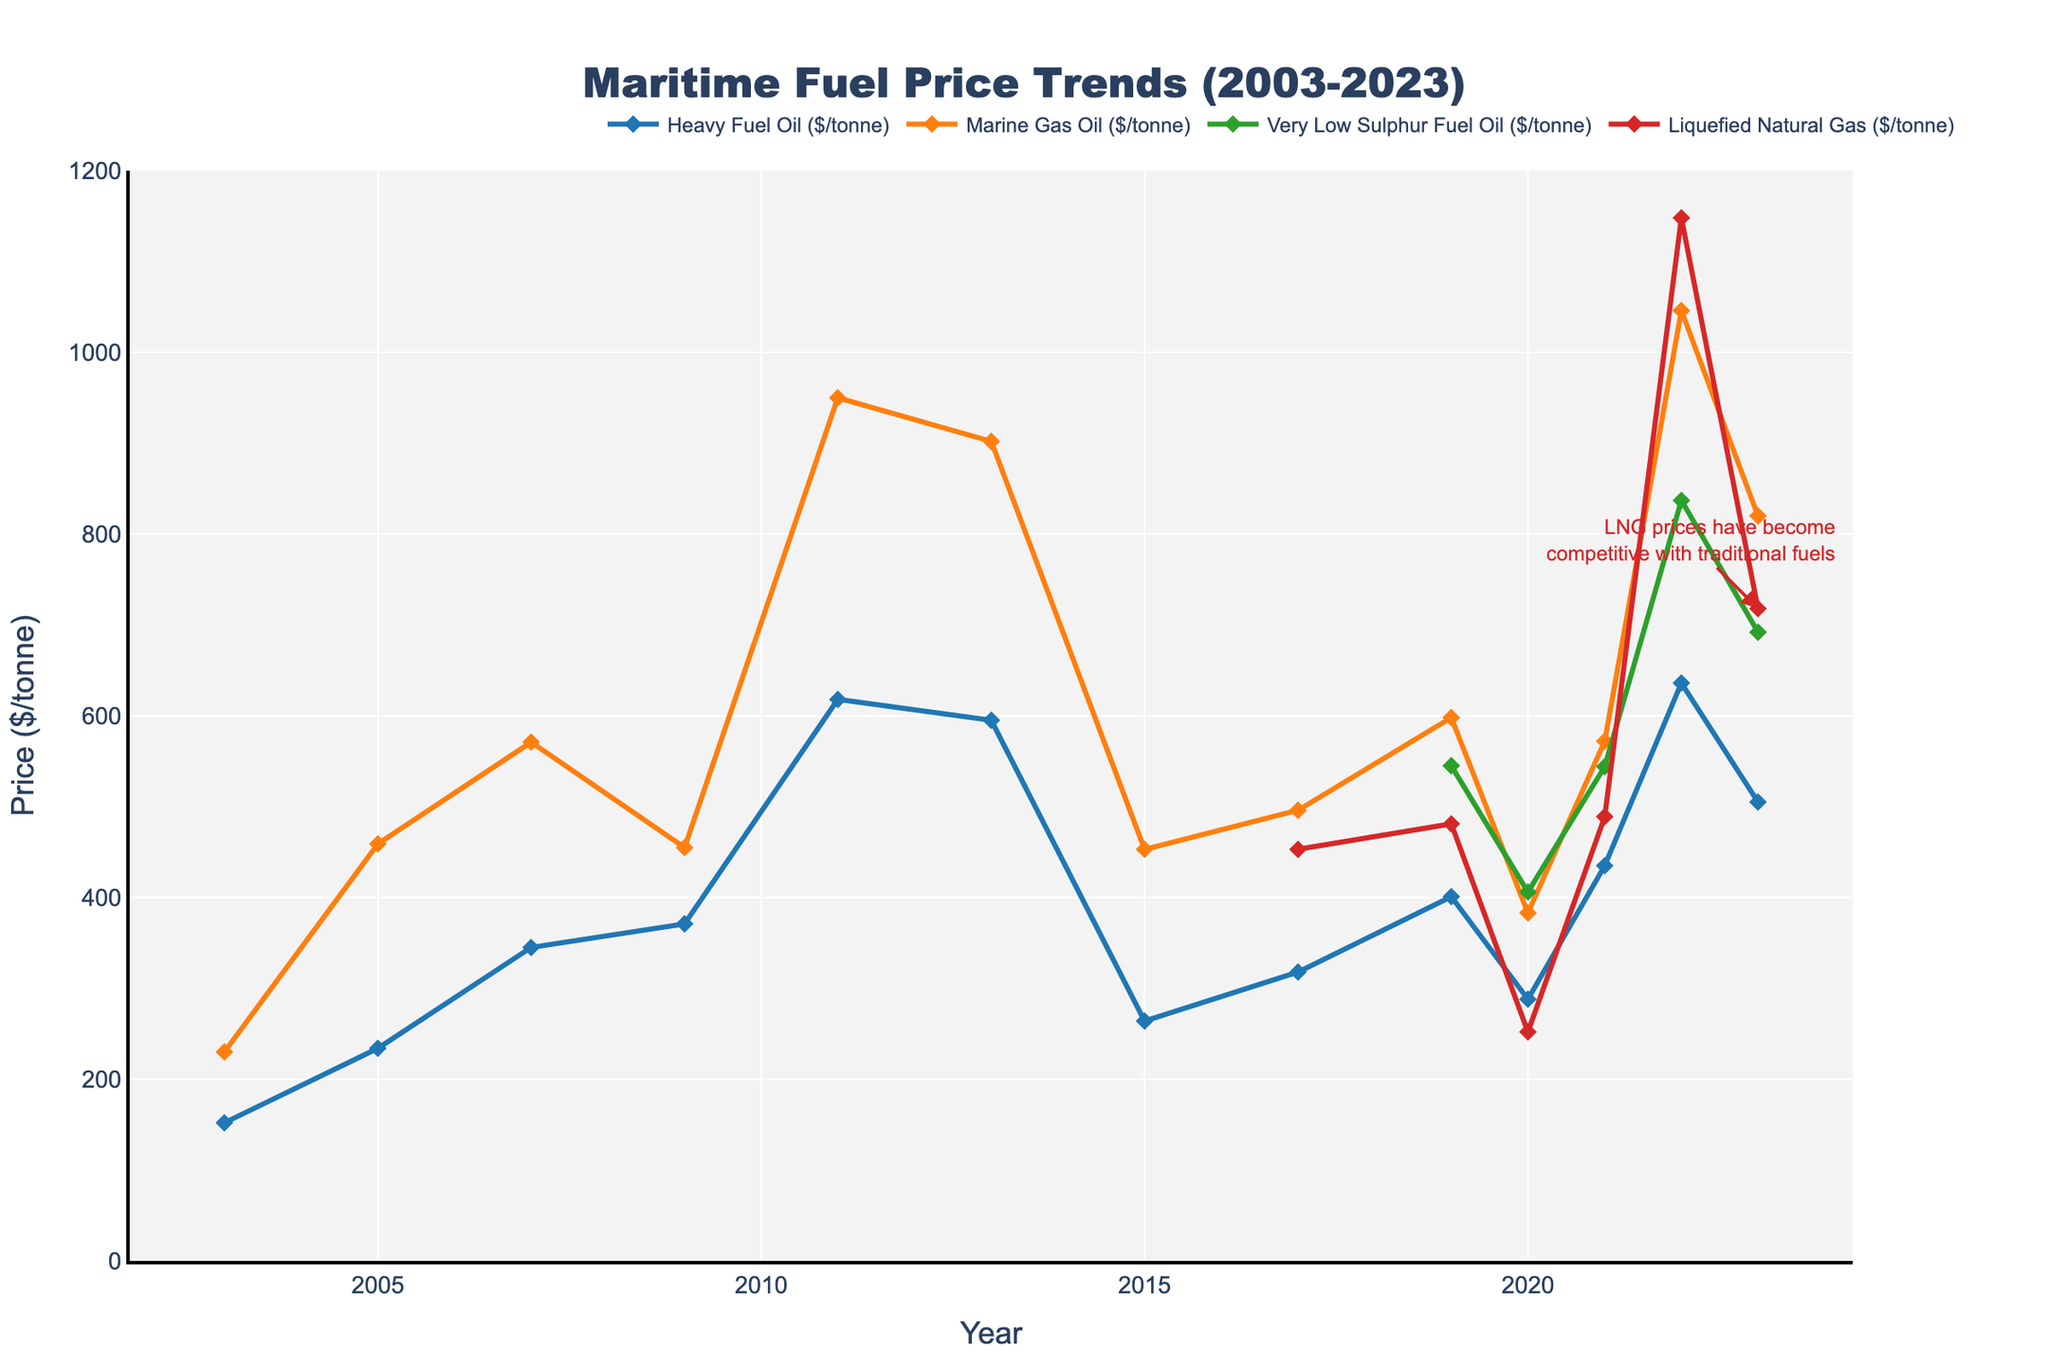What is the price trend of Heavy Fuel Oil (HFO) from 2005 to 2015? From the figure, locate the data points for HFO in 2005, 2007, 2009, 2011, 2013, and 2015. Observe how the price changes over these years. The price increases from 234 in 2005 to 371 in 2009, peaks at 618 in 2011, and decreases significantly to 264 in 2015.
Answer: Increase How do the prices of Marine Gas Oil (MGO) and Very Low Sulphur Fuel Oil (VLSFO) compare in 2019? From the figure, find the prices of MGO and VLSFO in 2019 by looking at the corresponding points on the graph. MGO is priced at 598 and VLSFO is priced at 545. Comparing these, MGO is higher.
Answer: MGO is higher Which year saw the highest price for Marine Gas Oil (MGO), and what was the price? Determine the highest point on the MGO curve, which appears around 2022. The price at this point, which is the highest, is approximately 1046.
Answer: 2022, 1046 What is the average price of Liquefied Natural Gas (LNG) over the years it is available on the chart? Sum the prices of LNG for the years available (2017, 2019, 2020, 2021, 2022, 2023) and divide by the number of years. The sum is 453 + 481 + 252 + 489 + 1148 + 718 = 3541. There are 6 years, so 3541/6 ≈ 590.
Answer: 590 Compare the price changes of VLSFO between 2019 and 2023. Locate the prices of VLSFO in 2019 and 2023 on the chart. In 2019, the price is about 545, and in 2023, it is about 692. Therefore, there is an increase.
Answer: Increase How did the price of Heavy Fuel Oil (HFO) fare from 2011 to 2015? Find the 2011 and 2015 HFO prices on the graph. The price drops significantly from 618 in 2011 to 264 in 2015.
Answer: Decrease Which fuel type showed the highest price increase from 2020 to 2022? Compare the price points for each fuel type between 2020 and 2022. HFO increases from 288 to 636, MGO from 383 to 1046, VLSFO from 406 to 837, and LNG from 252 to 1148. LNG shows the highest increase (1148 - 252 = 896).
Answer: LNG What is the most notable price trend for LNG between 2019 and 2023? Examine the LNG price curve from 2019 through 2023. The price starts at 481, drops to 252 in 2020, and then trends upwards to 718 in 2023, with a peak at 1148 in 2022. The trend is a steep rise after 2020.
Answer: Steep rise after 2020 